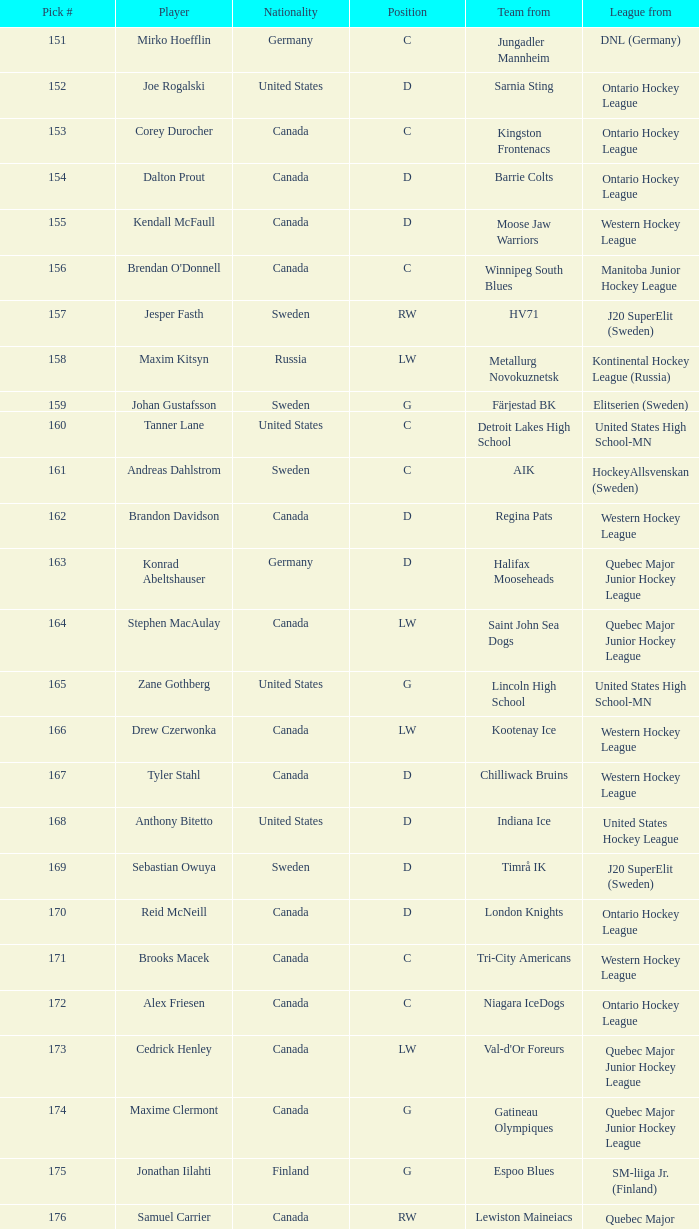What is the position of the team player from Aik? C. 